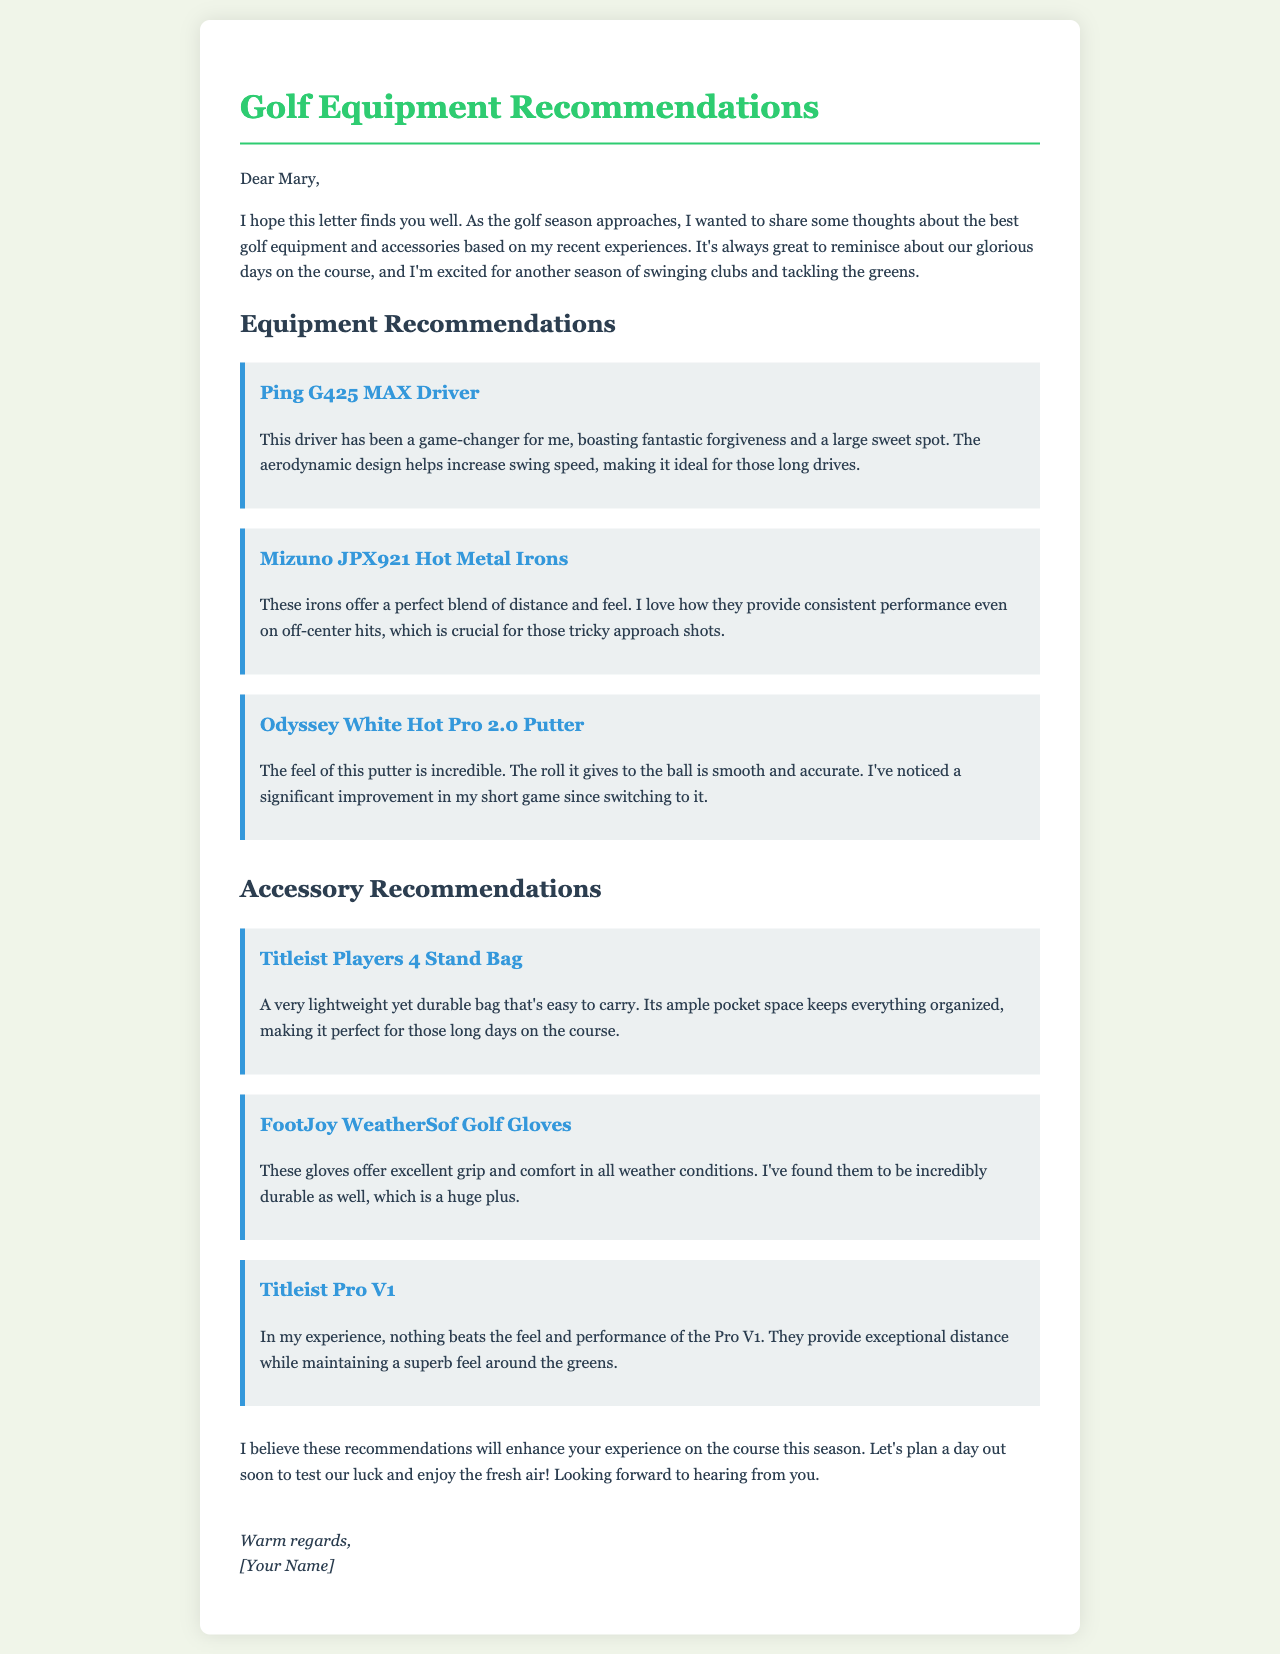What is the title of the letter? The title of the letter, as stated in the document, is "Golf Equipment Recommendations."
Answer: Golf Equipment Recommendations Who is the letter addressed to? The letter is addressed to Mary, as noted in the opening line.
Answer: Mary What equipment is recommended for long drives? The letter mentions the Ping G425 MAX Driver as a recommendation for long drives.
Answer: Ping G425 MAX Driver Which accessory is noted for its durability? The FootJoy WeatherSof Golf Gloves are highlighted for their durability in the document.
Answer: FootJoy WeatherSof Golf Gloves What is the main benefit of using the Odyssey White Hot Pro 2.0 Putter? The main benefit noted for the putter is the significant improvement in the short game.
Answer: Significant improvement in short game Which golf ball is considered exceptional in feel and performance? The Titleist Pro V1 is described as exemplary in feel and performance.
Answer: Titleist Pro V1 What specific feature does the Titleist Players 4 Stand Bag provide? The Titleist Players 4 Stand Bag features ample pocket space for organization.
Answer: Ample pocket space What is the overall purpose of the letter? The purpose of the letter is to share recommendations for golf equipment and accessories for the upcoming season.
Answer: Share recommendations What does the writer express excitement for? The writer expresses excitement for another season of golfing.
Answer: Another season of golfing 